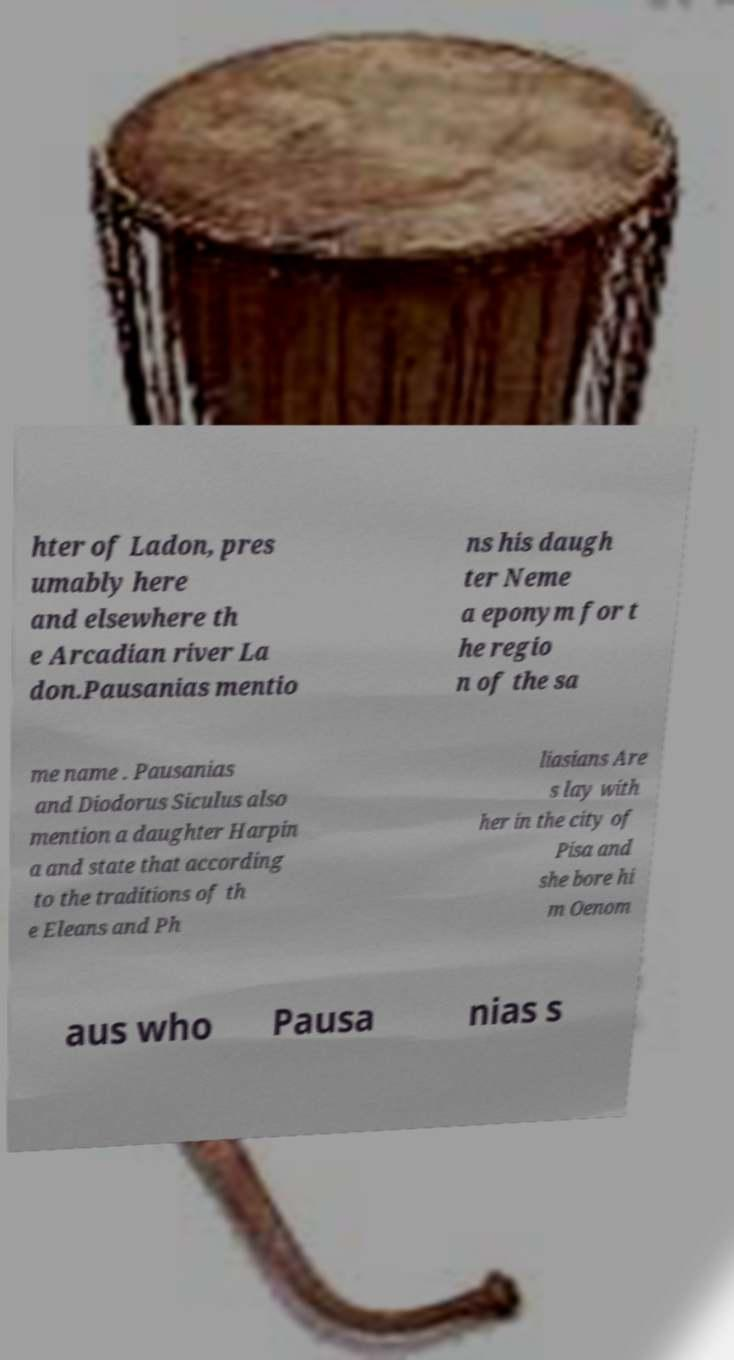For documentation purposes, I need the text within this image transcribed. Could you provide that? hter of Ladon, pres umably here and elsewhere th e Arcadian river La don.Pausanias mentio ns his daugh ter Neme a eponym for t he regio n of the sa me name . Pausanias and Diodorus Siculus also mention a daughter Harpin a and state that according to the traditions of th e Eleans and Ph liasians Are s lay with her in the city of Pisa and she bore hi m Oenom aus who Pausa nias s 